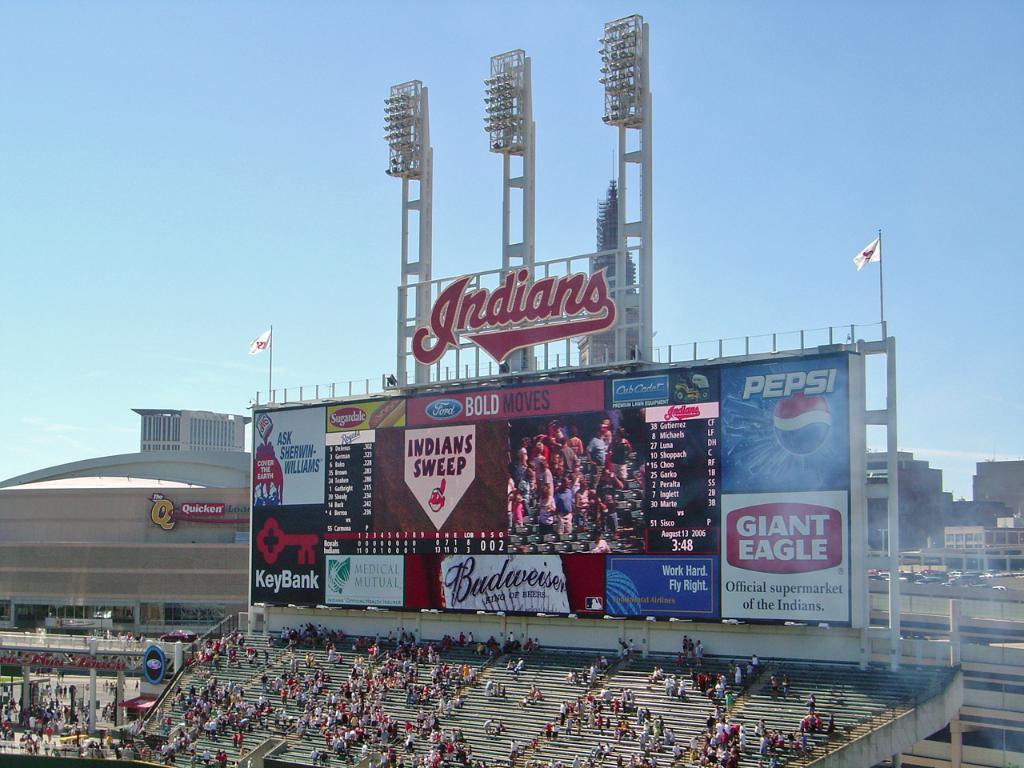<image>
Present a compact description of the photo's key features. A large outdoor stadium has spectators watching a game under a sign that says Indians. 